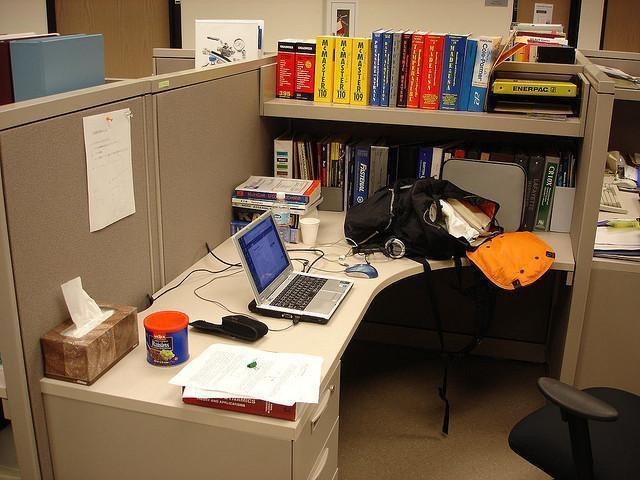What type of internet device is in use at this desk?
Answer the question by selecting the correct answer among the 4 following choices.
Options: Desktop computer, tablet, smartphone, laptop computer. Desktop computer. 